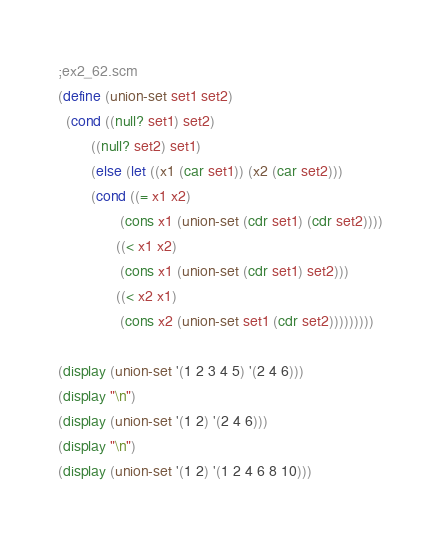Convert code to text. <code><loc_0><loc_0><loc_500><loc_500><_Scheme_>;ex2_62.scm
(define (union-set set1 set2)
  (cond ((null? set1) set2)
        ((null? set2) set1)
        (else (let ((x1 (car set1)) (x2 (car set2)))
        (cond ((= x1 x2)
               (cons x1 (union-set (cdr set1) (cdr set2))))
              ((< x1 x2)
               (cons x1 (union-set (cdr set1) set2)))
              ((< x2 x1)
               (cons x2 (union-set set1 (cdr set2)))))))))

(display (union-set '(1 2 3 4 5) '(2 4 6)))
(display "\n")
(display (union-set '(1 2) '(2 4 6)))
(display "\n")
(display (union-set '(1 2) '(1 2 4 6 8 10)))
</code> 